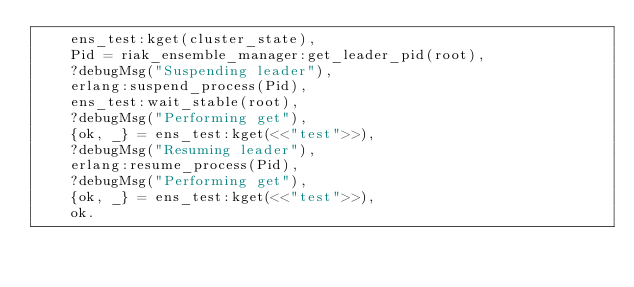<code> <loc_0><loc_0><loc_500><loc_500><_Erlang_>    ens_test:kget(cluster_state),
    Pid = riak_ensemble_manager:get_leader_pid(root),
    ?debugMsg("Suspending leader"),
    erlang:suspend_process(Pid),
    ens_test:wait_stable(root),
    ?debugMsg("Performing get"),
    {ok, _} = ens_test:kget(<<"test">>),
    ?debugMsg("Resuming leader"),
    erlang:resume_process(Pid),
    ?debugMsg("Performing get"),
    {ok, _} = ens_test:kget(<<"test">>),
    ok.
</code> 